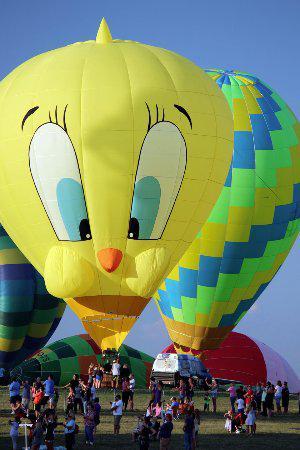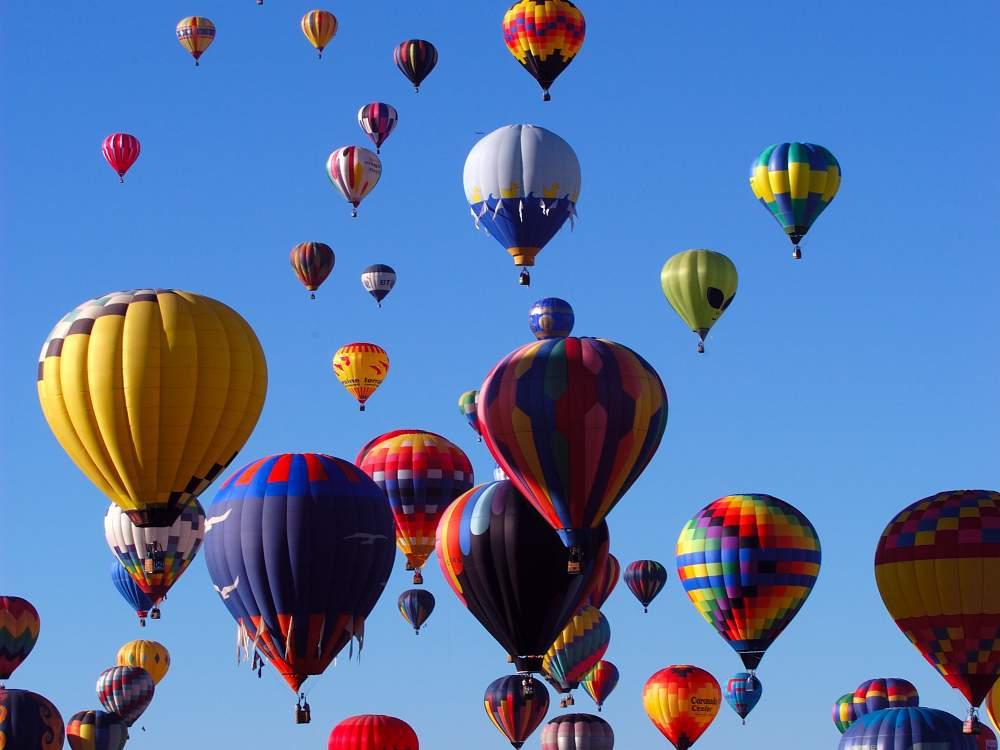The first image is the image on the left, the second image is the image on the right. Given the left and right images, does the statement "The left image features at least one but no more than two hot air balloons in the air a distance from the ground, and the right image includes a hot air balloon that is not in the air." hold true? Answer yes or no. No. The first image is the image on the left, the second image is the image on the right. Examine the images to the left and right. Is the description "At least one hot air balloon has a character's face on it." accurate? Answer yes or no. Yes. 